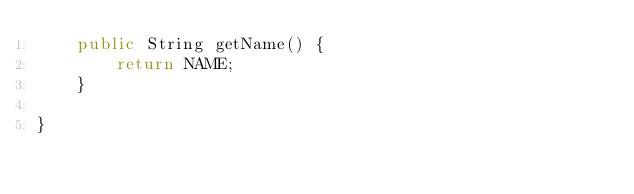Convert code to text. <code><loc_0><loc_0><loc_500><loc_500><_Java_>    public String getName() {
        return NAME;
    }

}
</code> 